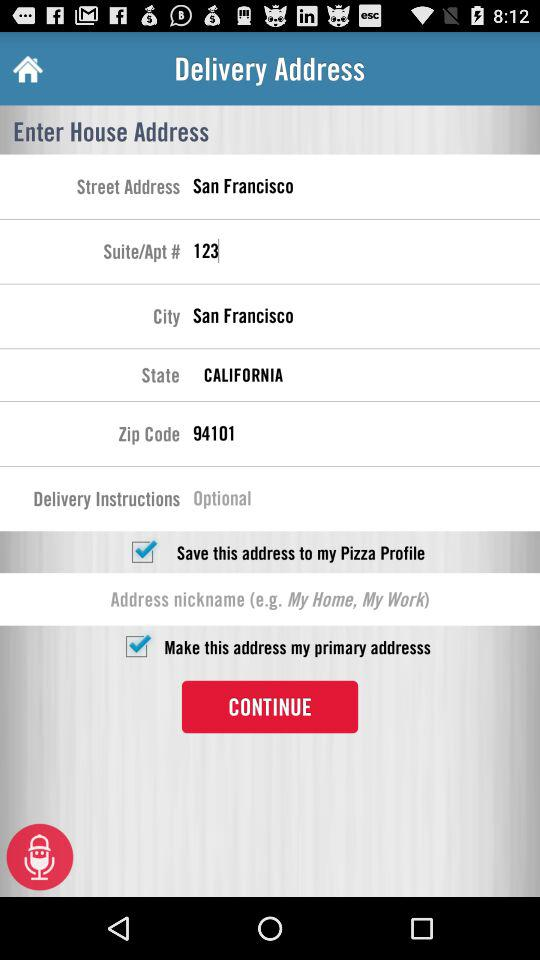What is the suite number? The suite number is 123. 